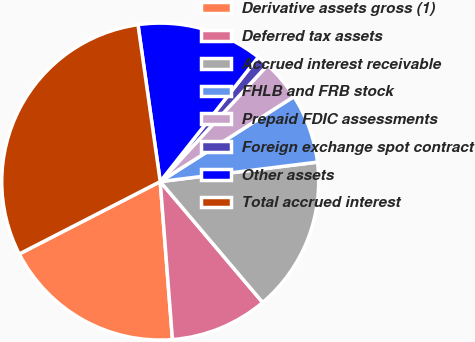Convert chart to OTSL. <chart><loc_0><loc_0><loc_500><loc_500><pie_chart><fcel>Derivative assets gross (1)<fcel>Deferred tax assets<fcel>Accrued interest receivable<fcel>FHLB and FRB stock<fcel>Prepaid FDIC assessments<fcel>Foreign exchange spot contract<fcel>Other assets<fcel>Total accrued interest<nl><fcel>18.68%<fcel>9.96%<fcel>15.77%<fcel>7.05%<fcel>4.14%<fcel>1.23%<fcel>12.86%<fcel>30.31%<nl></chart> 